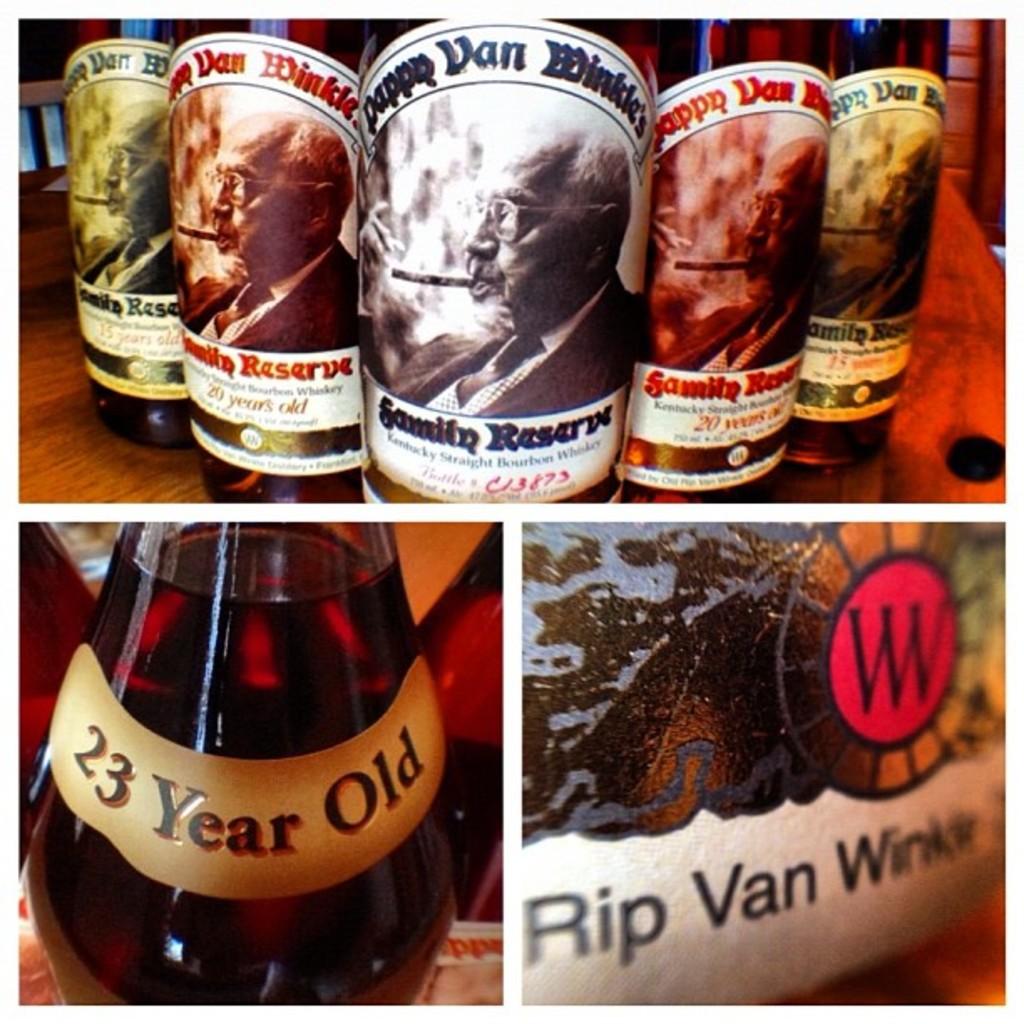What drinks are those?
Offer a very short reply. Whiskey. How old is the bottom left bottle?
Provide a short and direct response. 23. 